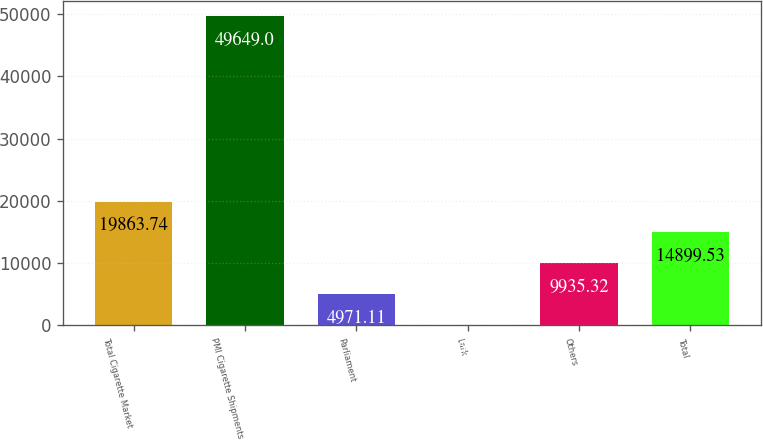Convert chart. <chart><loc_0><loc_0><loc_500><loc_500><bar_chart><fcel>Total Cigarette Market<fcel>PMI Cigarette Shipments<fcel>Parliament<fcel>Lark<fcel>Others<fcel>Total<nl><fcel>19863.7<fcel>49649<fcel>4971.11<fcel>6.9<fcel>9935.32<fcel>14899.5<nl></chart> 